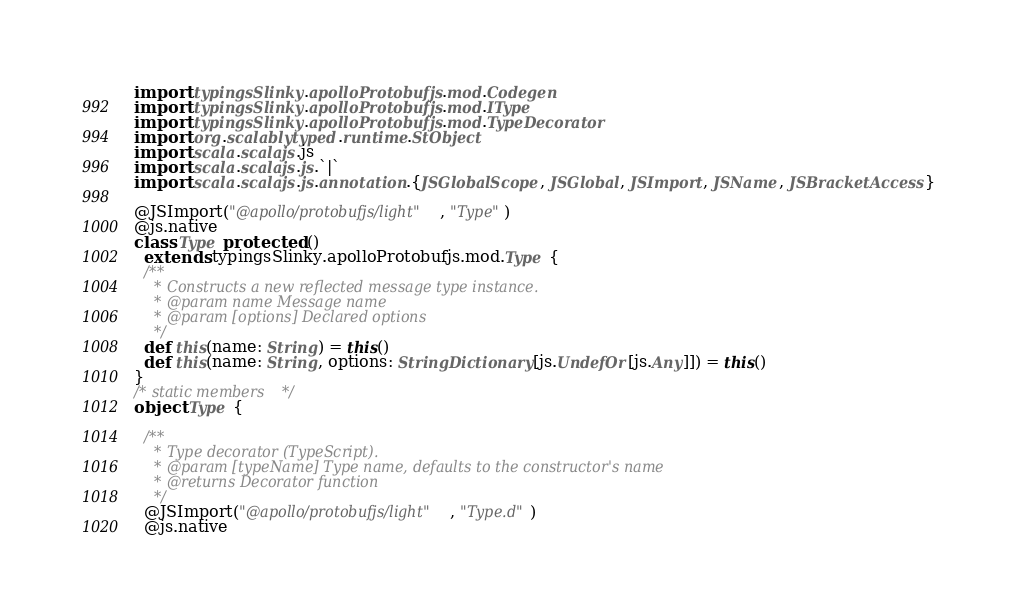<code> <loc_0><loc_0><loc_500><loc_500><_Scala_>import typingsSlinky.apolloProtobufjs.mod.Codegen
import typingsSlinky.apolloProtobufjs.mod.IType
import typingsSlinky.apolloProtobufjs.mod.TypeDecorator
import org.scalablytyped.runtime.StObject
import scala.scalajs.js
import scala.scalajs.js.`|`
import scala.scalajs.js.annotation.{JSGlobalScope, JSGlobal, JSImport, JSName, JSBracketAccess}

@JSImport("@apollo/protobufjs/light", "Type")
@js.native
class Type protected ()
  extends typingsSlinky.apolloProtobufjs.mod.Type {
  /**
    * Constructs a new reflected message type instance.
    * @param name Message name
    * @param [options] Declared options
    */
  def this(name: String) = this()
  def this(name: String, options: StringDictionary[js.UndefOr[js.Any]]) = this()
}
/* static members */
object Type {
  
  /**
    * Type decorator (TypeScript).
    * @param [typeName] Type name, defaults to the constructor's name
    * @returns Decorator function
    */
  @JSImport("@apollo/protobufjs/light", "Type.d")
  @js.native</code> 